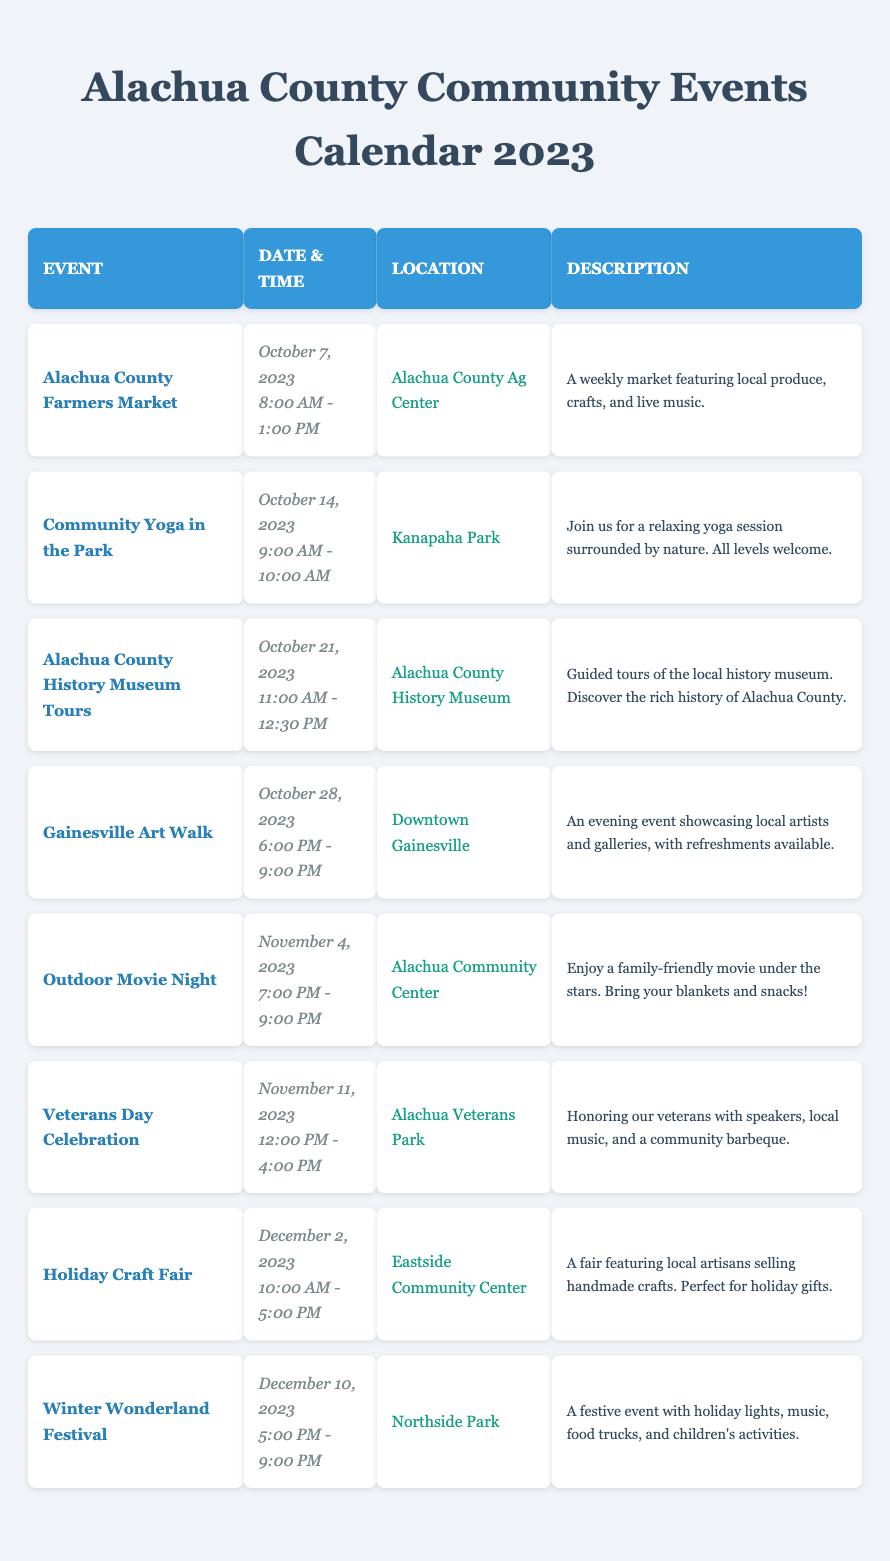What is the date of the Outdoor Movie Night? The table lists the events with their dates. By locating "Outdoor Movie Night", I can see it is scheduled for November 4, 2023.
Answer: November 4, 2023 Where is the Veterans Day Celebration taking place? The event details indicate the location for "Veterans Day Celebration" is "Alachua Veterans Park".
Answer: Alachua Veterans Park How long does the Holiday Craft Fair last? The Holiday Craft Fair begins at 10:00 AM and ends at 5:00 PM, which gives a total duration of 7 hours.
Answer: 7 hours Is the Gainesville Art Walk an evening event? The time for the Gainesville Art Walk is from 6:00 PM to 9:00 PM, confirming that it occurs in the evening.
Answer: Yes What events occur on the first Saturday of November? The first Saturday of November is November 4, 2023. Referring to the table, the only event on this date is "Outdoor Movie Night".
Answer: Outdoor Movie Night What time does Community Yoga in the Park start? According to the table, "Community Yoga in the Park" starts at 9:00 AM.
Answer: 9:00 AM Are there any events in December? The table shows two events in December: "Holiday Craft Fair" on December 2 and "Winter Wonderland Festival" on December 10.
Answer: Yes Which event takes place the day after Veterans Day? Veterans Day is on November 11, 2023. The next event is the "Holiday Craft Fair" on December 2, 2023.
Answer: Holiday Craft Fair How many hours of community events occur in total during October? The events in October are the Farmers Market (5 hours), Community Yoga (1 hour), Museum Tours (1.5 hours), and Gainesville Art Walk (3 hours). Summing these gives 10.5 hours of events.
Answer: 10.5 hours What is the total number of events scheduled in 2023? Counting the events listed provides a total of 8 events planned for 2023.
Answer: 8 events How many of the events are family-friendly? The events considered family-friendly, as noted in the descriptions, are "Outdoor Movie Night" and "Winter Wonderland Festival", making a total of 2 events.
Answer: 2 events 